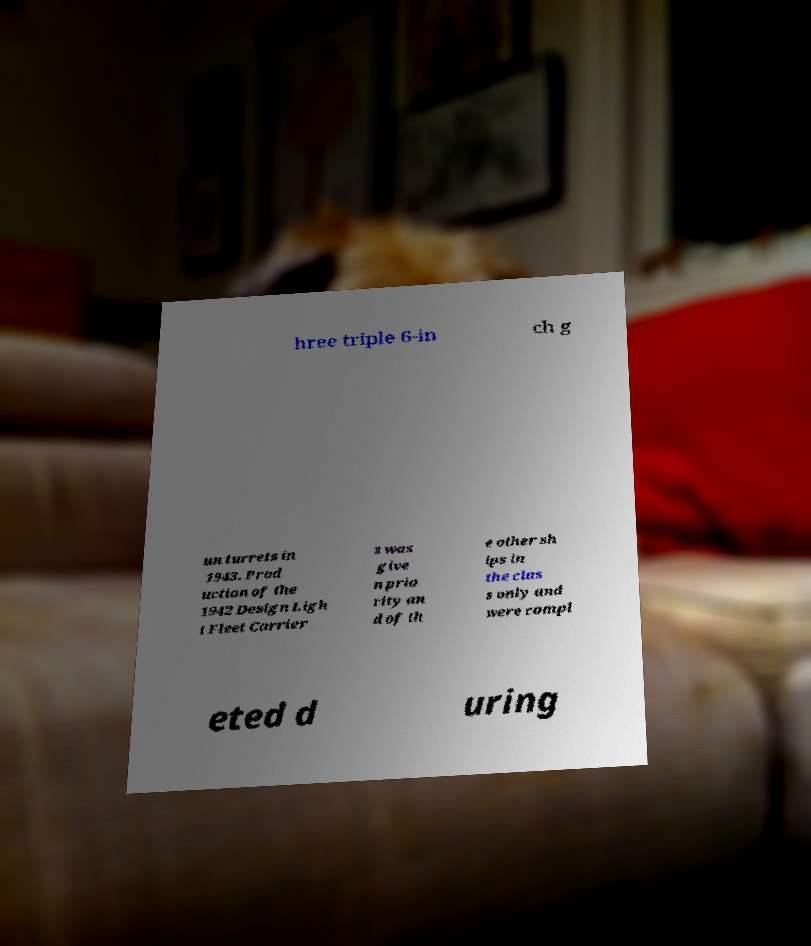Can you read and provide the text displayed in the image?This photo seems to have some interesting text. Can you extract and type it out for me? hree triple 6-in ch g un turrets in 1943. Prod uction of the 1942 Design Ligh t Fleet Carrier s was give n prio rity an d of th e other sh ips in the clas s only and were compl eted d uring 